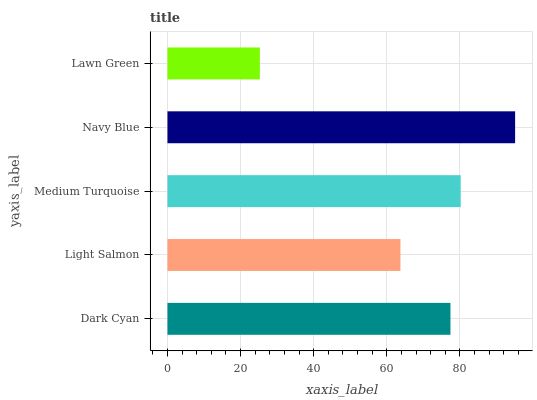Is Lawn Green the minimum?
Answer yes or no. Yes. Is Navy Blue the maximum?
Answer yes or no. Yes. Is Light Salmon the minimum?
Answer yes or no. No. Is Light Salmon the maximum?
Answer yes or no. No. Is Dark Cyan greater than Light Salmon?
Answer yes or no. Yes. Is Light Salmon less than Dark Cyan?
Answer yes or no. Yes. Is Light Salmon greater than Dark Cyan?
Answer yes or no. No. Is Dark Cyan less than Light Salmon?
Answer yes or no. No. Is Dark Cyan the high median?
Answer yes or no. Yes. Is Dark Cyan the low median?
Answer yes or no. Yes. Is Lawn Green the high median?
Answer yes or no. No. Is Navy Blue the low median?
Answer yes or no. No. 